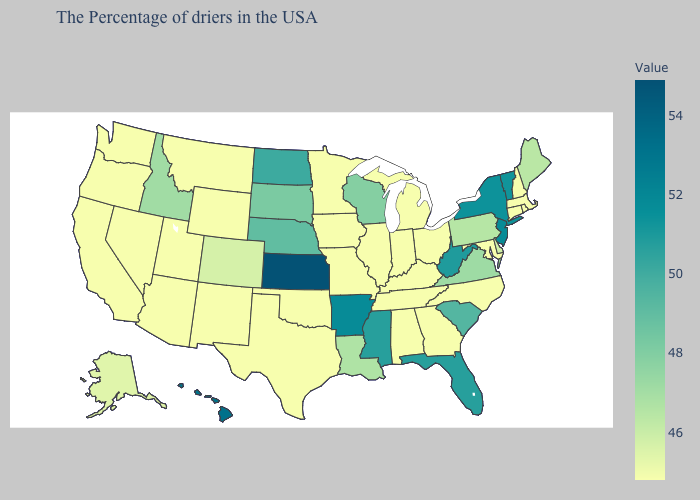Does Montana have the lowest value in the West?
Concise answer only. Yes. Which states have the lowest value in the South?
Answer briefly. Maryland, North Carolina, Georgia, Kentucky, Alabama, Tennessee, Oklahoma, Texas. 